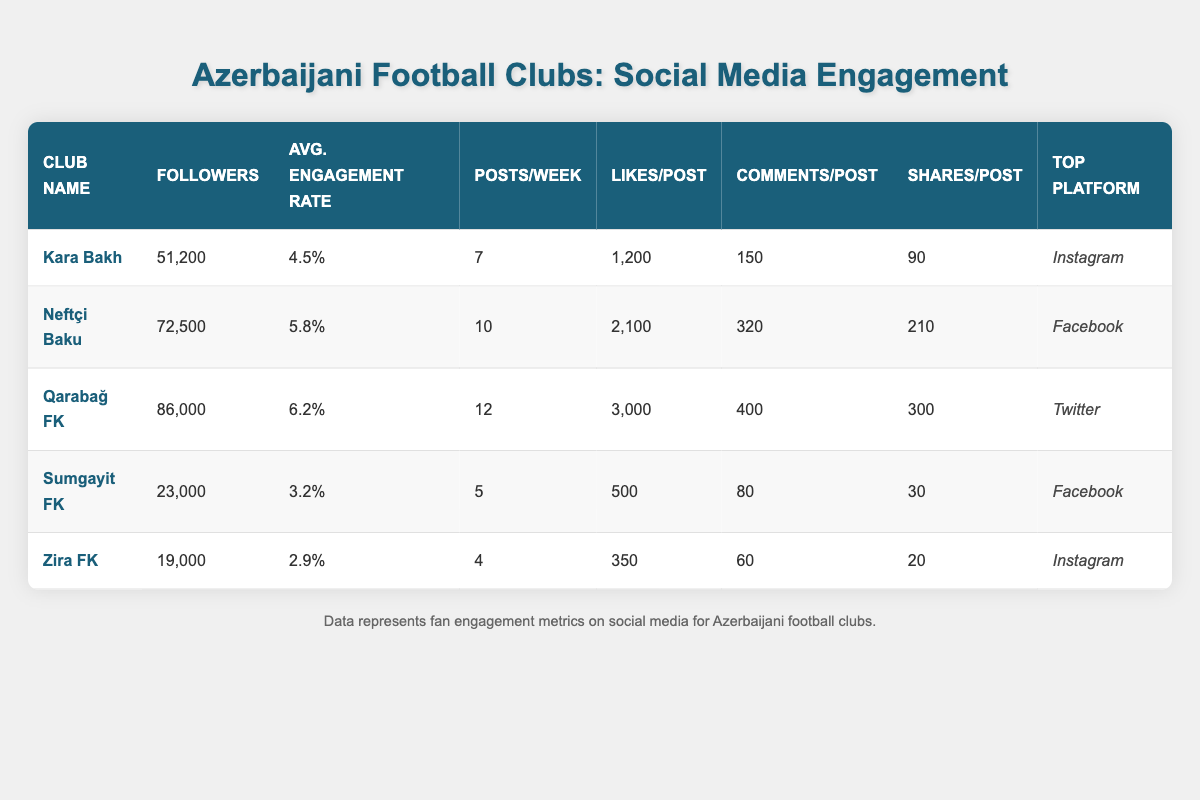What is the engagement rate for Qarabağ FK? From the table, the engagement rate for Qarabağ FK is listed under the 'Avg. Engagement Rate' column, which shows 6.2%.
Answer: 6.2% Which club has the highest number of followers? By examining the 'Followers' column, Qarabağ FK has the highest number with 86,000 followers, compared to the other clubs listed.
Answer: 86,000 What is the total number of likes per post for all clubs combined? Adding the likes per post for each club: (1200 + 2100 + 3000 + 500 + 350) =  10,250. Therefore, the total likes per post for all clubs is 10,250.
Answer: 10,250 Does Zira FK have a higher engagement rate than Sumgayit FK? According to the table, Zira FK has an engagement rate of 2.9%, while Sumgayit FK has 3.2%. Therefore, Zira FK does not have a higher engagement rate than Sumgayit FK.
Answer: No Which club posts the most frequently on social media? By looking at the 'Posts/Week' column, Qarabağ FK posts the most frequently, with 12 posts per week, more than any other club listed.
Answer: 12 posts/week What is the average number of shares per post across all clubs? To calculate the average number of shares per post, first sum the shares: (90 + 210 + 300 + 30 + 20) = 650. Then divide by the number of clubs (5): 650/5 = 130.
Answer: 130 Is Instagram the top platform for any club? The 'Top Platform' column shows that Kara Bakh and Zira FK list Instagram as their top platform, confirming that it is a top platform for some clubs.
Answer: Yes Which club has the lowest average engagement rate? By inspecting the 'Avg. Engagement Rate' column, Zira FK has the lowest rate at 2.9%, compared to all other clubs.
Answer: Zira FK What is the difference in followers between Neftçi Baku and Sumgayit FK? Neftçi Baku has 72,500 followers and Sumgayit FK has 23,000. The difference is calculated as 72,500 - 23,000 = 49,500.
Answer: 49,500 